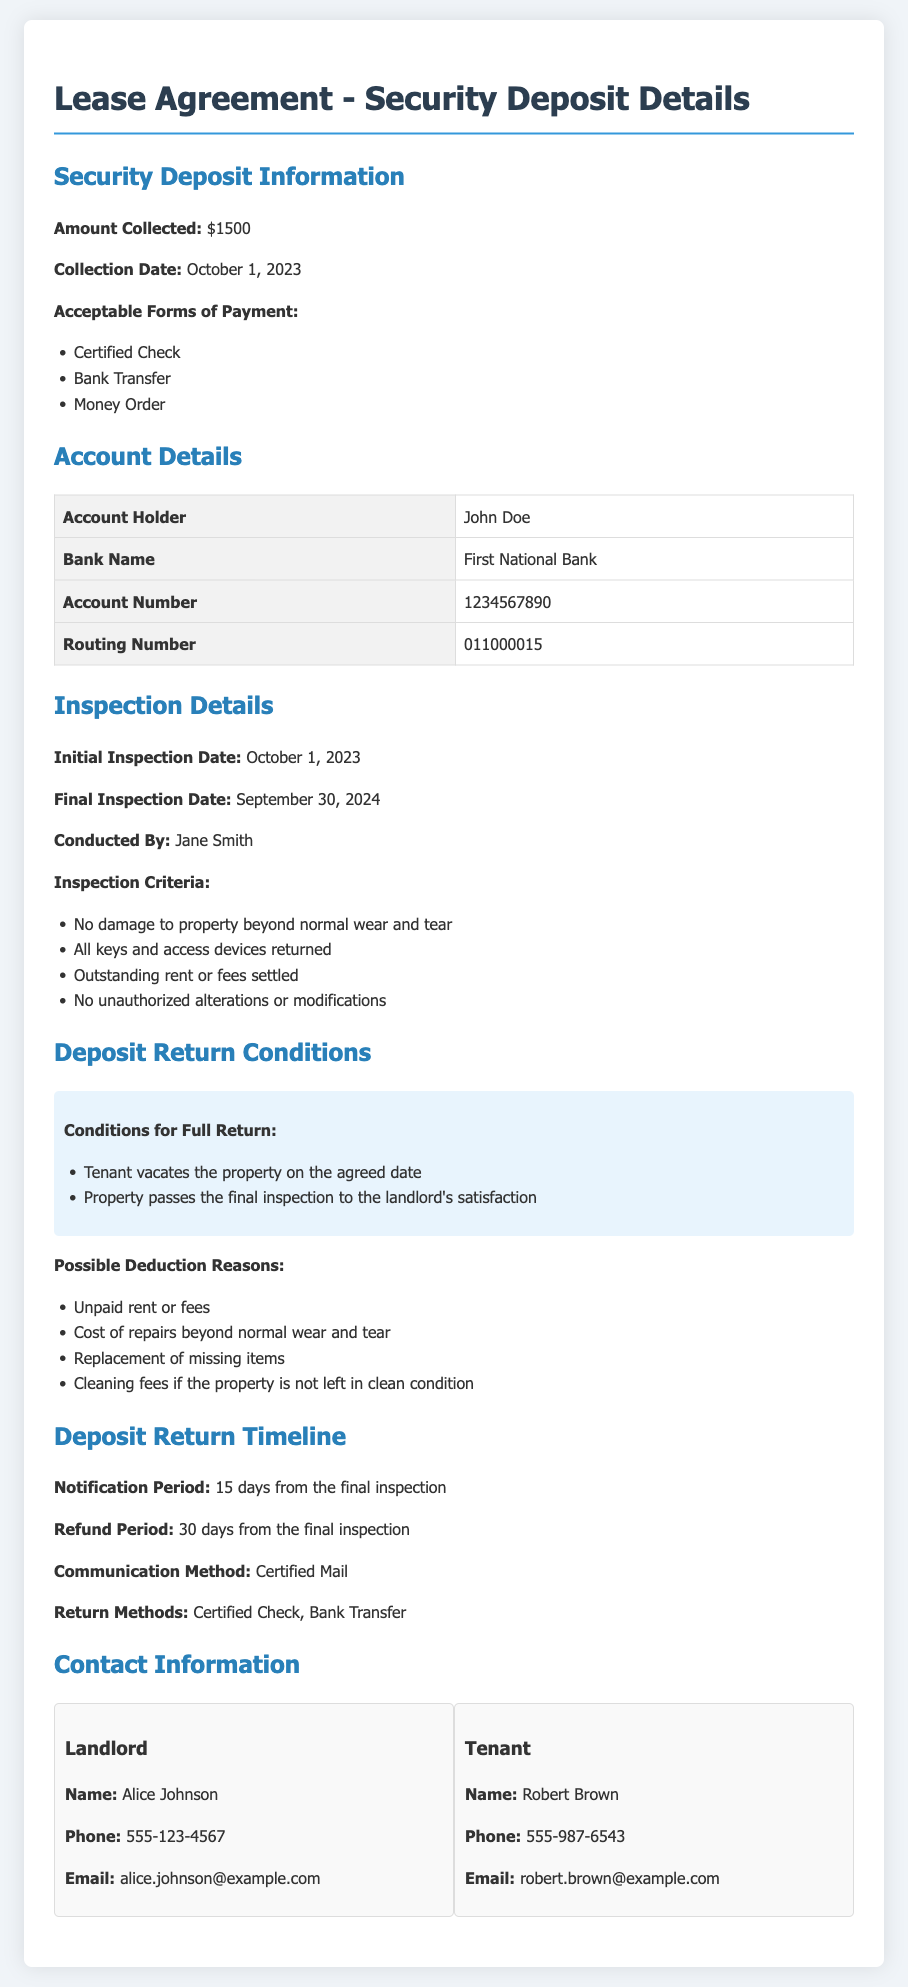What is the amount of the security deposit? The document specifies the amount collected for the security deposit, which is stated clearly.
Answer: $1500 Who conducted the final inspection? The final inspection details list the person who conducted the inspection.
Answer: Jane Smith What is the refund period for the security deposit? The document outlines the timeline for the deposit return and specifies the duration for refund processing.
Answer: 30 days What method will be used for communication regarding the deposit return? The document mentions the official communication method for notifying about the deposit return.
Answer: Certified Mail What conditions must be met for a full return of the deposit? The document clearly states the criteria that need to be satisfied for the full return of the deposit.
Answer: Tenant vacates the property on the agreed date and property passes the final inspection to the landlord's satisfaction What are acceptable forms of payment for the security deposit? The document lists acceptable payment methods for the security deposit explicitly.
Answer: Certified Check, Bank Transfer, Money Order What is the notification period after the final inspection? The document specifies the time frame for notifying the tenant regarding the deposit after inspection.
Answer: 15 days What is the account holder's name on the bank account? The document provides information on the account associated with the security deposit.
Answer: John Doe 